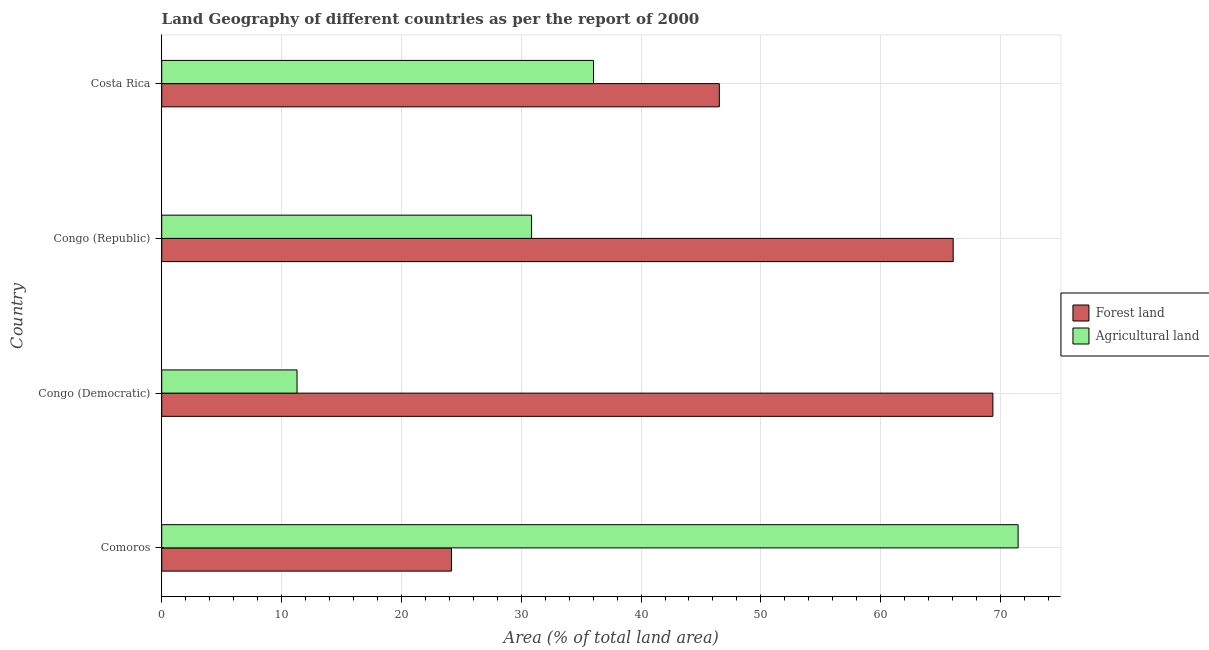How many different coloured bars are there?
Your answer should be very brief. 2. How many groups of bars are there?
Keep it short and to the point. 4. How many bars are there on the 1st tick from the top?
Ensure brevity in your answer.  2. How many bars are there on the 2nd tick from the bottom?
Your response must be concise. 2. What is the label of the 3rd group of bars from the top?
Provide a short and direct response. Congo (Democratic). In how many cases, is the number of bars for a given country not equal to the number of legend labels?
Provide a short and direct response. 0. What is the percentage of land area under forests in Congo (Republic)?
Give a very brief answer. 66.05. Across all countries, what is the maximum percentage of land area under forests?
Your answer should be very brief. 69.36. Across all countries, what is the minimum percentage of land area under agriculture?
Your response must be concise. 11.29. In which country was the percentage of land area under forests maximum?
Provide a succinct answer. Congo (Democratic). In which country was the percentage of land area under agriculture minimum?
Make the answer very short. Congo (Democratic). What is the total percentage of land area under agriculture in the graph?
Give a very brief answer. 149.66. What is the difference between the percentage of land area under agriculture in Congo (Republic) and that in Costa Rica?
Your answer should be compact. -5.17. What is the difference between the percentage of land area under agriculture in Comoros and the percentage of land area under forests in Congo (Republic)?
Ensure brevity in your answer.  5.42. What is the average percentage of land area under forests per country?
Give a very brief answer. 51.53. What is the difference between the percentage of land area under agriculture and percentage of land area under forests in Congo (Democratic)?
Provide a succinct answer. -58.07. What is the ratio of the percentage of land area under agriculture in Comoros to that in Costa Rica?
Provide a succinct answer. 1.98. Is the percentage of land area under agriculture in Congo (Democratic) less than that in Costa Rica?
Your answer should be very brief. Yes. What is the difference between the highest and the second highest percentage of land area under agriculture?
Provide a short and direct response. 35.43. What is the difference between the highest and the lowest percentage of land area under forests?
Make the answer very short. 45.18. What does the 2nd bar from the top in Comoros represents?
Give a very brief answer. Forest land. What does the 2nd bar from the bottom in Congo (Democratic) represents?
Keep it short and to the point. Agricultural land. Are the values on the major ticks of X-axis written in scientific E-notation?
Offer a very short reply. No. Does the graph contain grids?
Keep it short and to the point. Yes. Where does the legend appear in the graph?
Make the answer very short. Center right. How many legend labels are there?
Ensure brevity in your answer.  2. How are the legend labels stacked?
Provide a succinct answer. Vertical. What is the title of the graph?
Make the answer very short. Land Geography of different countries as per the report of 2000. What is the label or title of the X-axis?
Your answer should be very brief. Area (% of total land area). What is the Area (% of total land area) in Forest land in Comoros?
Your response must be concise. 24.18. What is the Area (% of total land area) of Agricultural land in Comoros?
Your answer should be compact. 71.47. What is the Area (% of total land area) of Forest land in Congo (Democratic)?
Your answer should be compact. 69.36. What is the Area (% of total land area) of Agricultural land in Congo (Democratic)?
Give a very brief answer. 11.29. What is the Area (% of total land area) in Forest land in Congo (Republic)?
Offer a very short reply. 66.05. What is the Area (% of total land area) of Agricultural land in Congo (Republic)?
Provide a short and direct response. 30.86. What is the Area (% of total land area) in Forest land in Costa Rica?
Keep it short and to the point. 46.53. What is the Area (% of total land area) of Agricultural land in Costa Rica?
Provide a short and direct response. 36.04. Across all countries, what is the maximum Area (% of total land area) in Forest land?
Ensure brevity in your answer.  69.36. Across all countries, what is the maximum Area (% of total land area) of Agricultural land?
Make the answer very short. 71.47. Across all countries, what is the minimum Area (% of total land area) in Forest land?
Provide a short and direct response. 24.18. Across all countries, what is the minimum Area (% of total land area) of Agricultural land?
Provide a short and direct response. 11.29. What is the total Area (% of total land area) in Forest land in the graph?
Give a very brief answer. 206.13. What is the total Area (% of total land area) in Agricultural land in the graph?
Make the answer very short. 149.66. What is the difference between the Area (% of total land area) of Forest land in Comoros and that in Congo (Democratic)?
Give a very brief answer. -45.18. What is the difference between the Area (% of total land area) of Agricultural land in Comoros and that in Congo (Democratic)?
Keep it short and to the point. 60.17. What is the difference between the Area (% of total land area) of Forest land in Comoros and that in Congo (Republic)?
Keep it short and to the point. -41.87. What is the difference between the Area (% of total land area) in Agricultural land in Comoros and that in Congo (Republic)?
Ensure brevity in your answer.  40.6. What is the difference between the Area (% of total land area) of Forest land in Comoros and that in Costa Rica?
Your response must be concise. -22.35. What is the difference between the Area (% of total land area) in Agricultural land in Comoros and that in Costa Rica?
Offer a very short reply. 35.43. What is the difference between the Area (% of total land area) in Forest land in Congo (Democratic) and that in Congo (Republic)?
Keep it short and to the point. 3.31. What is the difference between the Area (% of total land area) in Agricultural land in Congo (Democratic) and that in Congo (Republic)?
Give a very brief answer. -19.57. What is the difference between the Area (% of total land area) of Forest land in Congo (Democratic) and that in Costa Rica?
Provide a succinct answer. 22.83. What is the difference between the Area (% of total land area) in Agricultural land in Congo (Democratic) and that in Costa Rica?
Provide a short and direct response. -24.74. What is the difference between the Area (% of total land area) in Forest land in Congo (Republic) and that in Costa Rica?
Provide a succinct answer. 19.52. What is the difference between the Area (% of total land area) in Agricultural land in Congo (Republic) and that in Costa Rica?
Ensure brevity in your answer.  -5.17. What is the difference between the Area (% of total land area) in Forest land in Comoros and the Area (% of total land area) in Agricultural land in Congo (Democratic)?
Your answer should be compact. 12.89. What is the difference between the Area (% of total land area) in Forest land in Comoros and the Area (% of total land area) in Agricultural land in Congo (Republic)?
Your response must be concise. -6.68. What is the difference between the Area (% of total land area) of Forest land in Comoros and the Area (% of total land area) of Agricultural land in Costa Rica?
Your response must be concise. -11.86. What is the difference between the Area (% of total land area) in Forest land in Congo (Democratic) and the Area (% of total land area) in Agricultural land in Congo (Republic)?
Give a very brief answer. 38.5. What is the difference between the Area (% of total land area) of Forest land in Congo (Democratic) and the Area (% of total land area) of Agricultural land in Costa Rica?
Give a very brief answer. 33.33. What is the difference between the Area (% of total land area) in Forest land in Congo (Republic) and the Area (% of total land area) in Agricultural land in Costa Rica?
Ensure brevity in your answer.  30.01. What is the average Area (% of total land area) of Forest land per country?
Your answer should be compact. 51.53. What is the average Area (% of total land area) of Agricultural land per country?
Make the answer very short. 37.41. What is the difference between the Area (% of total land area) of Forest land and Area (% of total land area) of Agricultural land in Comoros?
Offer a very short reply. -47.29. What is the difference between the Area (% of total land area) of Forest land and Area (% of total land area) of Agricultural land in Congo (Democratic)?
Offer a very short reply. 58.07. What is the difference between the Area (% of total land area) in Forest land and Area (% of total land area) in Agricultural land in Congo (Republic)?
Give a very brief answer. 35.19. What is the difference between the Area (% of total land area) in Forest land and Area (% of total land area) in Agricultural land in Costa Rica?
Give a very brief answer. 10.5. What is the ratio of the Area (% of total land area) of Forest land in Comoros to that in Congo (Democratic)?
Keep it short and to the point. 0.35. What is the ratio of the Area (% of total land area) of Agricultural land in Comoros to that in Congo (Democratic)?
Give a very brief answer. 6.33. What is the ratio of the Area (% of total land area) of Forest land in Comoros to that in Congo (Republic)?
Your answer should be very brief. 0.37. What is the ratio of the Area (% of total land area) of Agricultural land in Comoros to that in Congo (Republic)?
Offer a terse response. 2.32. What is the ratio of the Area (% of total land area) of Forest land in Comoros to that in Costa Rica?
Provide a short and direct response. 0.52. What is the ratio of the Area (% of total land area) in Agricultural land in Comoros to that in Costa Rica?
Provide a short and direct response. 1.98. What is the ratio of the Area (% of total land area) of Forest land in Congo (Democratic) to that in Congo (Republic)?
Your answer should be very brief. 1.05. What is the ratio of the Area (% of total land area) of Agricultural land in Congo (Democratic) to that in Congo (Republic)?
Provide a short and direct response. 0.37. What is the ratio of the Area (% of total land area) of Forest land in Congo (Democratic) to that in Costa Rica?
Your response must be concise. 1.49. What is the ratio of the Area (% of total land area) in Agricultural land in Congo (Democratic) to that in Costa Rica?
Provide a succinct answer. 0.31. What is the ratio of the Area (% of total land area) in Forest land in Congo (Republic) to that in Costa Rica?
Provide a succinct answer. 1.42. What is the ratio of the Area (% of total land area) of Agricultural land in Congo (Republic) to that in Costa Rica?
Offer a very short reply. 0.86. What is the difference between the highest and the second highest Area (% of total land area) of Forest land?
Offer a very short reply. 3.31. What is the difference between the highest and the second highest Area (% of total land area) of Agricultural land?
Keep it short and to the point. 35.43. What is the difference between the highest and the lowest Area (% of total land area) in Forest land?
Your answer should be compact. 45.18. What is the difference between the highest and the lowest Area (% of total land area) of Agricultural land?
Your response must be concise. 60.17. 